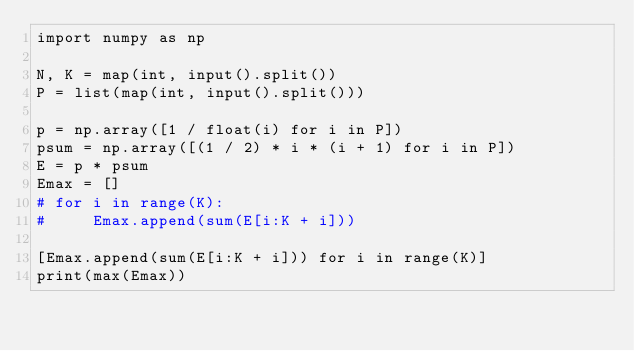<code> <loc_0><loc_0><loc_500><loc_500><_Python_>import numpy as np

N, K = map(int, input().split())
P = list(map(int, input().split()))

p = np.array([1 / float(i) for i in P])
psum = np.array([(1 / 2) * i * (i + 1) for i in P])
E = p * psum
Emax = []
# for i in range(K):
#     Emax.append(sum(E[i:K + i]))

[Emax.append(sum(E[i:K + i])) for i in range(K)]
print(max(Emax))
</code> 